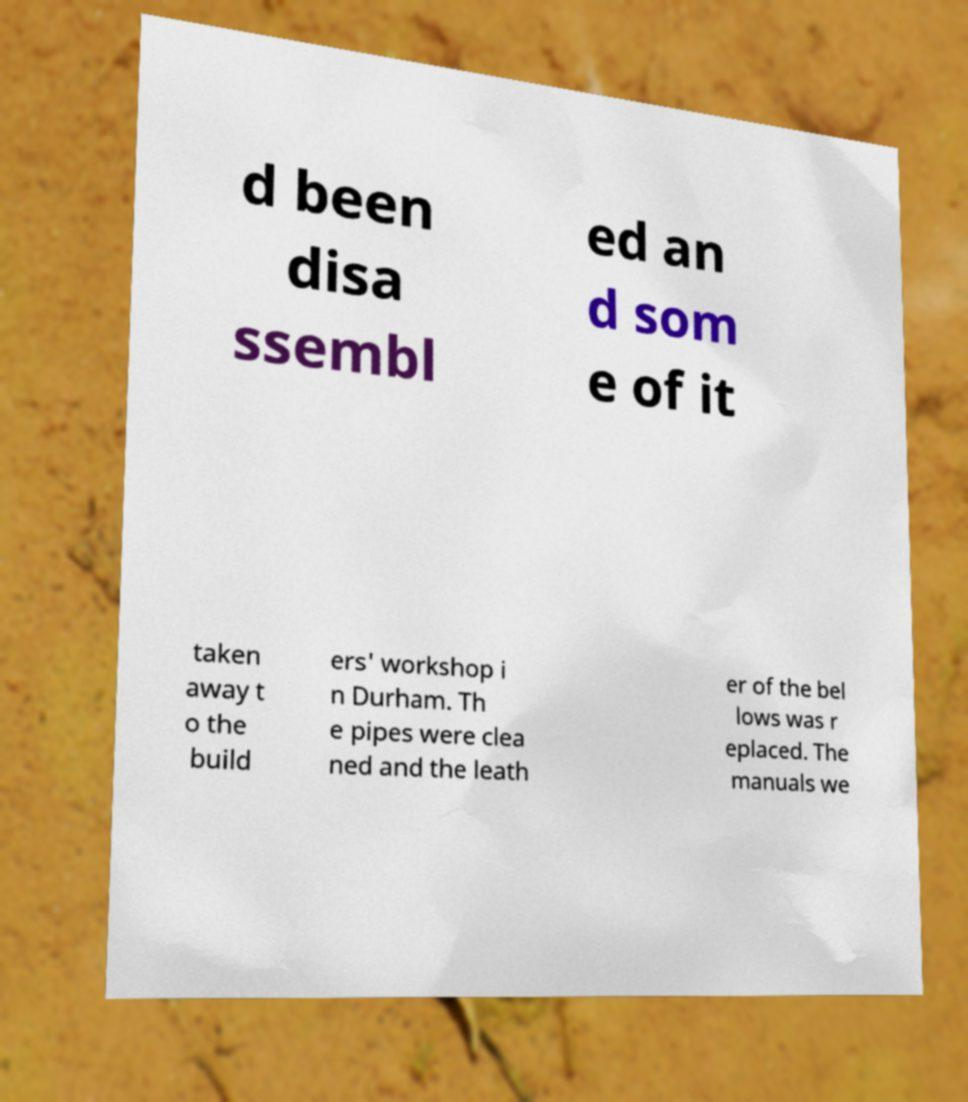Please read and relay the text visible in this image. What does it say? d been disa ssembl ed an d som e of it taken away t o the build ers' workshop i n Durham. Th e pipes were clea ned and the leath er of the bel lows was r eplaced. The manuals we 